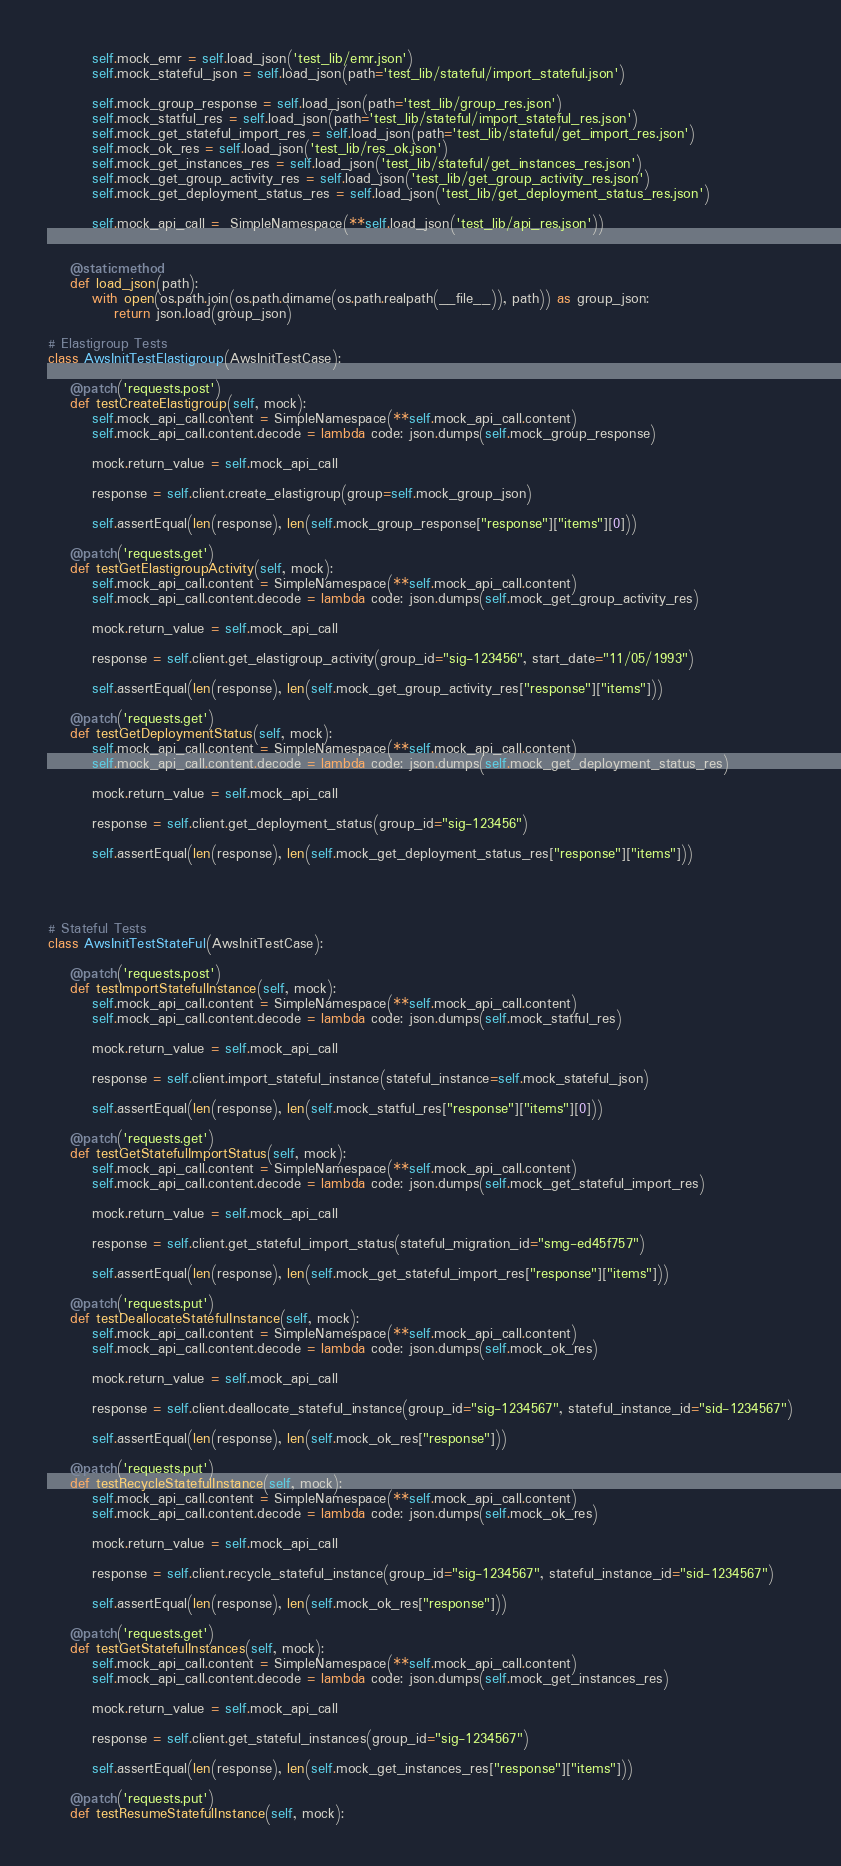<code> <loc_0><loc_0><loc_500><loc_500><_Python_>		self.mock_emr = self.load_json('test_lib/emr.json')
		self.mock_stateful_json = self.load_json(path='test_lib/stateful/import_stateful.json')

		self.mock_group_response = self.load_json(path='test_lib/group_res.json')
		self.mock_statful_res = self.load_json(path='test_lib/stateful/import_stateful_res.json')
		self.mock_get_stateful_import_res = self.load_json(path='test_lib/stateful/get_import_res.json')
		self.mock_ok_res = self.load_json('test_lib/res_ok.json')
		self.mock_get_instances_res = self.load_json('test_lib/stateful/get_instances_res.json')
		self.mock_get_group_activity_res = self.load_json('test_lib/get_group_activity_res.json')
		self.mock_get_deployment_status_res = self.load_json('test_lib/get_deployment_status_res.json')

		self.mock_api_call =  SimpleNamespace(**self.load_json('test_lib/api_res.json'))


	@staticmethod
	def load_json(path):
		with open(os.path.join(os.path.dirname(os.path.realpath(__file__)), path)) as group_json:
			return json.load(group_json)

# Elastigroup Tests
class AwsInitTestElastigroup(AwsInitTestCase):

	@patch('requests.post')
	def testCreateElastigroup(self, mock):
		self.mock_api_call.content = SimpleNamespace(**self.mock_api_call.content)
		self.mock_api_call.content.decode = lambda code: json.dumps(self.mock_group_response)

		mock.return_value = self.mock_api_call

		response = self.client.create_elastigroup(group=self.mock_group_json)

		self.assertEqual(len(response), len(self.mock_group_response["response"]["items"][0]))

	@patch('requests.get')
	def testGetElastigroupActivity(self, mock):
		self.mock_api_call.content = SimpleNamespace(**self.mock_api_call.content)
		self.mock_api_call.content.decode = lambda code: json.dumps(self.mock_get_group_activity_res)

		mock.return_value = self.mock_api_call

		response = self.client.get_elastigroup_activity(group_id="sig-123456", start_date="11/05/1993")

		self.assertEqual(len(response), len(self.mock_get_group_activity_res["response"]["items"]))

	@patch('requests.get')
	def testGetDeploymentStatus(self, mock):
		self.mock_api_call.content = SimpleNamespace(**self.mock_api_call.content)
		self.mock_api_call.content.decode = lambda code: json.dumps(self.mock_get_deployment_status_res) 

		mock.return_value = self.mock_api_call

		response = self.client.get_deployment_status(group_id="sig-123456")

		self.assertEqual(len(response), len(self.mock_get_deployment_status_res["response"]["items"]))




# Stateful Tests
class AwsInitTestStateFul(AwsInitTestCase):

	@patch('requests.post')
	def testImportStatefulInstance(self, mock):
		self.mock_api_call.content = SimpleNamespace(**self.mock_api_call.content)
		self.mock_api_call.content.decode = lambda code: json.dumps(self.mock_statful_res) 

		mock.return_value = self.mock_api_call

		response = self.client.import_stateful_instance(stateful_instance=self.mock_stateful_json)

		self.assertEqual(len(response), len(self.mock_statful_res["response"]["items"][0]))

	@patch('requests.get')
	def testGetStatefulImportStatus(self, mock):
		self.mock_api_call.content = SimpleNamespace(**self.mock_api_call.content)
		self.mock_api_call.content.decode = lambda code: json.dumps(self.mock_get_stateful_import_res) 

		mock.return_value = self.mock_api_call

		response = self.client.get_stateful_import_status(stateful_migration_id="smg-ed45f757")

		self.assertEqual(len(response), len(self.mock_get_stateful_import_res["response"]["items"]))

	@patch('requests.put')
	def testDeallocateStatefulInstance(self, mock):
		self.mock_api_call.content = SimpleNamespace(**self.mock_api_call.content)
		self.mock_api_call.content.decode = lambda code: json.dumps(self.mock_ok_res) 

		mock.return_value = self.mock_api_call

		response = self.client.deallocate_stateful_instance(group_id="sig-1234567", stateful_instance_id="sid-1234567")

		self.assertEqual(len(response), len(self.mock_ok_res["response"]))

	@patch('requests.put')
	def testRecycleStatefulInstance(self, mock):
		self.mock_api_call.content = SimpleNamespace(**self.mock_api_call.content)
		self.mock_api_call.content.decode = lambda code: json.dumps(self.mock_ok_res) 

		mock.return_value = self.mock_api_call

		response = self.client.recycle_stateful_instance(group_id="sig-1234567", stateful_instance_id="sid-1234567")

		self.assertEqual(len(response), len(self.mock_ok_res["response"]))

	@patch('requests.get')
	def testGetStatefulInstances(self, mock):
		self.mock_api_call.content = SimpleNamespace(**self.mock_api_call.content)
		self.mock_api_call.content.decode = lambda code: json.dumps(self.mock_get_instances_res)

		mock.return_value = self.mock_api_call

		response = self.client.get_stateful_instances(group_id="sig-1234567")

		self.assertEqual(len(response), len(self.mock_get_instances_res["response"]["items"]))

	@patch('requests.put')
	def testResumeStatefulInstance(self, mock):</code> 